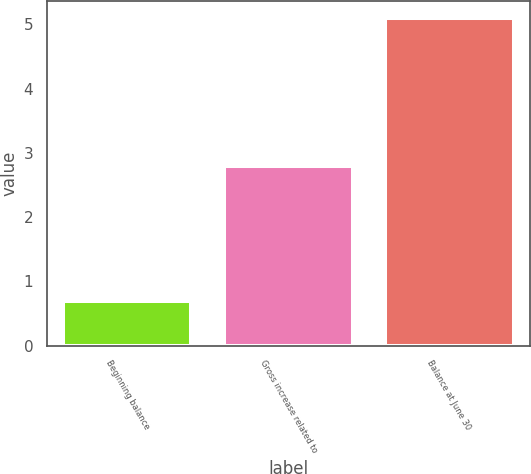Convert chart to OTSL. <chart><loc_0><loc_0><loc_500><loc_500><bar_chart><fcel>Beginning balance<fcel>Gross increase related to<fcel>Balance at June 30<nl><fcel>0.7<fcel>2.8<fcel>5.1<nl></chart> 